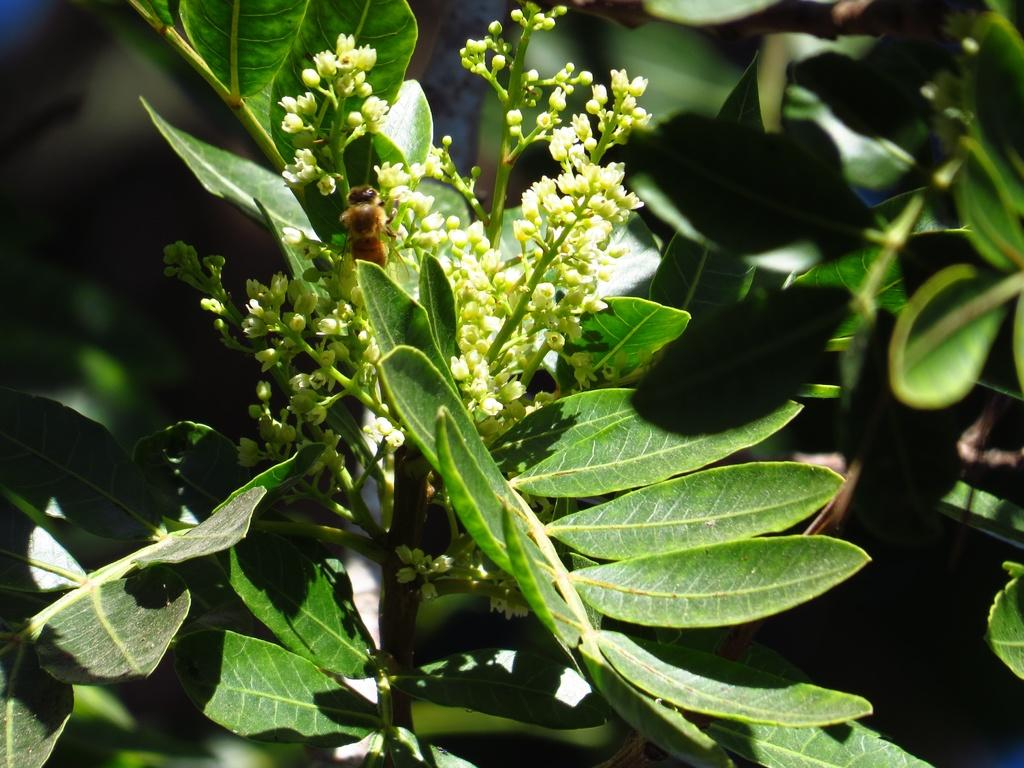What type of living organism is present in the image? There is a plant in the image. What are the main features of the plant? The plant has leaves and flowers. Is there any interaction between the plant and other elements in the image? Yes, there is a bee on the flowers. What color is the crayon used to draw the house in the image? There is no house or crayon present in the image; it features a plant with leaves and flowers, and a bee on the flowers. 